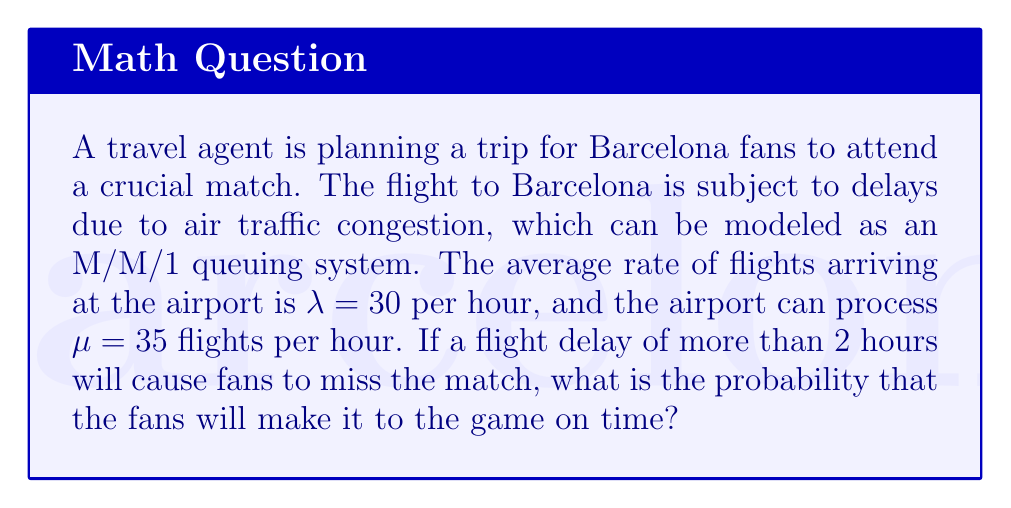Give your solution to this math problem. To solve this problem, we'll use the M/M/1 queuing system and follow these steps:

1. Calculate the utilization factor ρ:
   $$ \rho = \frac{\lambda}{\mu} = \frac{30}{35} \approx 0.8571 $$

2. The probability of having n flights in the system is given by:
   $$ P(n) = (1 - \rho) \rho^n $$

3. The probability of the waiting time W exceeding a certain value t is:
   $$ P(W > t) = e^{-\mu(1-\rho)t} $$

4. In our case, we want the probability of the waiting time being less than or equal to 2 hours:
   $$ P(W \leq 2) = 1 - P(W > 2) = 1 - e^{-\mu(1-\rho)2} $$

5. Substituting the values:
   $$ P(W \leq 2) = 1 - e^{-35(1-0.8571)2} $$
   $$ = 1 - e^{-35(0.1429)2} $$
   $$ = 1 - e^{-10.003} $$
   $$ \approx 0.9999547 $$

6. Convert to percentage:
   $$ 0.9999547 \times 100\% \approx 99.99547\% $$

Therefore, the probability that the fans will make it to the game on time is approximately 99.99547%.
Answer: 99.99547% 